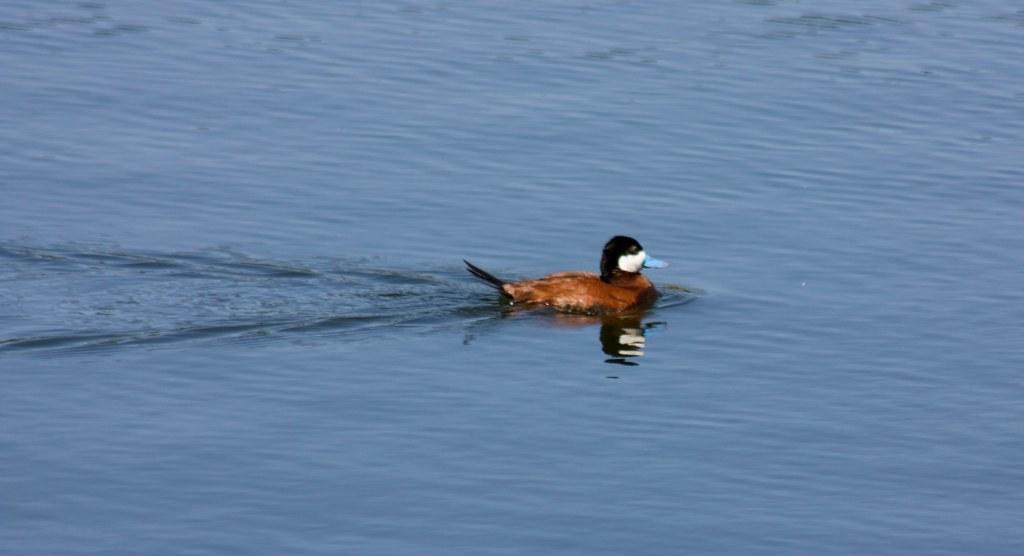Please provide a concise description of this image. In this picture there is a duck in the water. There is a reflection of duck on the water. 